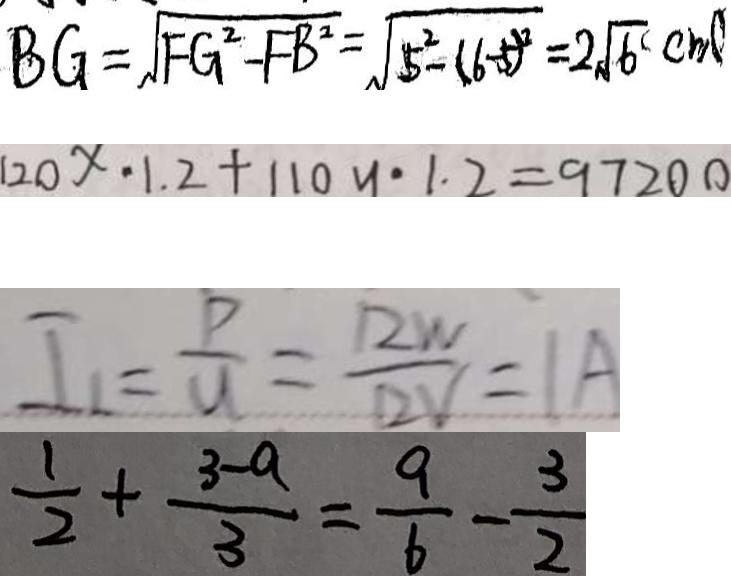Convert formula to latex. <formula><loc_0><loc_0><loc_500><loc_500>B G = \sqrt { F G ^ { 2 } - F B ^ { 2 } } = \sqrt { 5 ^ { 2 } - ( 6 - 5 ) ^ { 2 } } = 2 \sqrt { 6 } ( c m ) 
 1 2 0 x - 1 . 2 + 1 1 0 y \cdot 1 . 2 = 9 7 2 0 0 
 I _ { 1 } = \frac { P } { U } = \frac { 1 2 W } { 1 2 V } = 1 A 
 \frac { 1 } { 2 } + \frac { 3 - a } { 3 } = \frac { 9 } { 6 } - \frac { 3 } { 2 }</formula> 